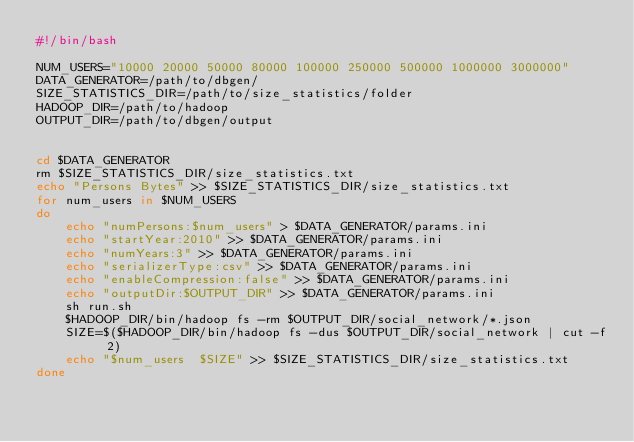<code> <loc_0><loc_0><loc_500><loc_500><_Bash_>#!/bin/bash

NUM_USERS="10000 20000 50000 80000 100000 250000 500000 1000000 3000000"
DATA_GENERATOR=/path/to/dbgen/
SIZE_STATISTICS_DIR=/path/to/size_statistics/folder
HADOOP_DIR=/path/to/hadoop
OUTPUT_DIR=/path/to/dbgen/output


cd $DATA_GENERATOR 
rm $SIZE_STATISTICS_DIR/size_statistics.txt
echo "Persons Bytes" >> $SIZE_STATISTICS_DIR/size_statistics.txt
for num_users in $NUM_USERS
do 
	echo "numPersons:$num_users" > $DATA_GENERATOR/params.ini
	echo "startYear:2010" >> $DATA_GENERATOR/params.ini
	echo "numYears:3" >> $DATA_GENERATOR/params.ini
	echo "serializerType:csv" >> $DATA_GENERATOR/params.ini
	echo "enableCompression:false" >> $DATA_GENERATOR/params.ini
	echo "outputDir:$OUTPUT_DIR" >> $DATA_GENERATOR/params.ini
	sh run.sh
	$HADOOP_DIR/bin/hadoop fs -rm $OUTPUT_DIR/social_network/*.json
	SIZE=$($HADOOP_DIR/bin/hadoop fs -dus $OUTPUT_DIR/social_network | cut -f 2)
	echo "$num_users  $SIZE" >> $SIZE_STATISTICS_DIR/size_statistics.txt
done 

</code> 